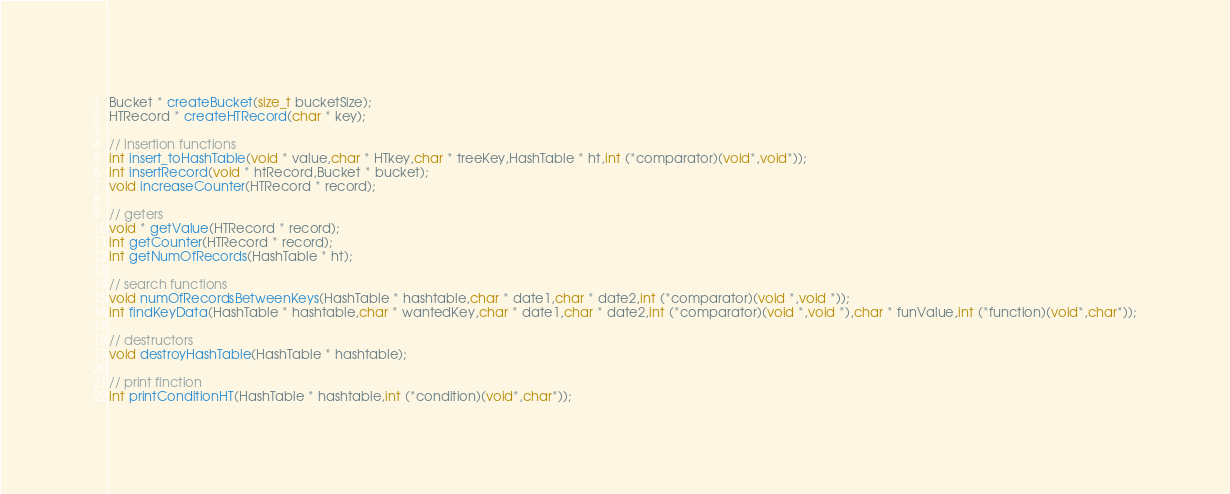<code> <loc_0><loc_0><loc_500><loc_500><_C_>Bucket * createBucket(size_t bucketSize);
HTRecord * createHTRecord(char * key);

// insertion functions
int insert_toHashTable(void * value,char * HTkey,char * treeKey,HashTable * ht,int (*comparator)(void*,void*));
int insertRecord(void * htRecord,Bucket * bucket);
void increaseCounter(HTRecord * record);

// geters
void * getValue(HTRecord * record);
int getCounter(HTRecord * record);
int getNumOfRecords(HashTable * ht);

// search functions
void numOfRecordsBetweenKeys(HashTable * hashtable,char * date1,char * date2,int (*comparator)(void *,void *));
int findKeyData(HashTable * hashtable,char * wantedKey,char * date1,char * date2,int (*comparator)(void *,void *),char * funValue,int (*function)(void*,char*));

// destructors
void destroyHashTable(HashTable * hashtable);

// print finction
int printConditionHT(HashTable * hashtable,int (*condition)(void*,char*));

</code> 